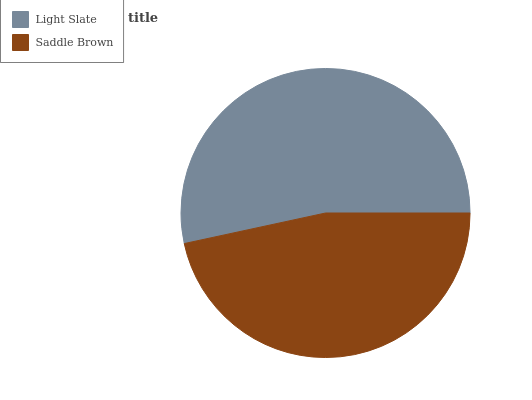Is Saddle Brown the minimum?
Answer yes or no. Yes. Is Light Slate the maximum?
Answer yes or no. Yes. Is Saddle Brown the maximum?
Answer yes or no. No. Is Light Slate greater than Saddle Brown?
Answer yes or no. Yes. Is Saddle Brown less than Light Slate?
Answer yes or no. Yes. Is Saddle Brown greater than Light Slate?
Answer yes or no. No. Is Light Slate less than Saddle Brown?
Answer yes or no. No. Is Light Slate the high median?
Answer yes or no. Yes. Is Saddle Brown the low median?
Answer yes or no. Yes. Is Saddle Brown the high median?
Answer yes or no. No. Is Light Slate the low median?
Answer yes or no. No. 